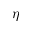Convert formula to latex. <formula><loc_0><loc_0><loc_500><loc_500>\eta</formula> 